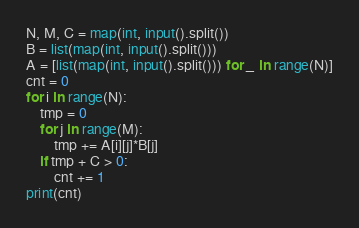<code> <loc_0><loc_0><loc_500><loc_500><_Python_>N, M, C = map(int, input().split())
B = list(map(int, input().split()))
A = [list(map(int, input().split())) for _ in range(N)]
cnt = 0
for i in range(N):
    tmp = 0
    for j in range(M):
        tmp += A[i][j]*B[j]
    if tmp + C > 0:
        cnt += 1
print(cnt)
</code> 